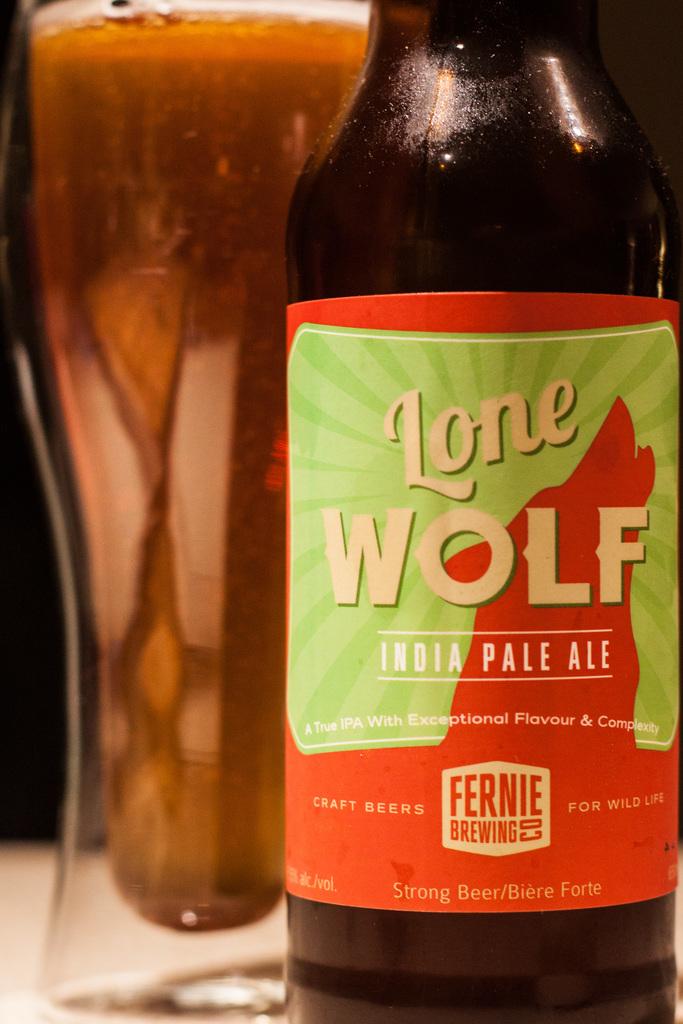What is the brewing company?
Make the answer very short. Fernie. 